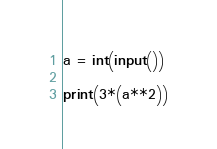<code> <loc_0><loc_0><loc_500><loc_500><_Python_>a = int(input())

print(3*(a**2))</code> 